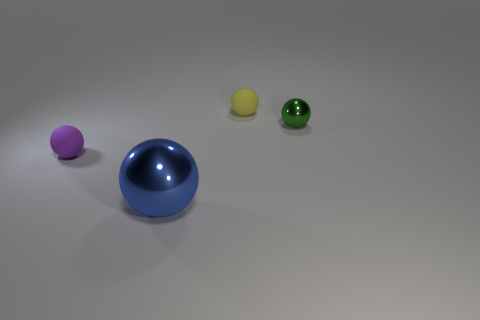Are the small thing right of the tiny yellow ball and the blue ball made of the same material?
Keep it short and to the point. Yes. The other ball that is made of the same material as the big blue sphere is what color?
Your answer should be very brief. Green. Is the number of small yellow rubber things left of the small purple thing less than the number of big metal balls on the left side of the large blue object?
Offer a very short reply. No. Do the matte ball that is on the right side of the purple thing and the metallic sphere that is in front of the tiny metal object have the same color?
Offer a very short reply. No. Is there a green cylinder made of the same material as the blue thing?
Your answer should be very brief. No. What size is the rubber sphere that is on the right side of the thing that is in front of the purple rubber ball?
Make the answer very short. Small. Is the number of green spheres greater than the number of small matte balls?
Keep it short and to the point. No. There is a rubber sphere that is in front of the green metallic sphere; does it have the same size as the big blue object?
Ensure brevity in your answer.  No. Is the shape of the purple thing the same as the big shiny thing?
Keep it short and to the point. Yes. Are there any other things that have the same size as the blue metallic thing?
Make the answer very short. No. 